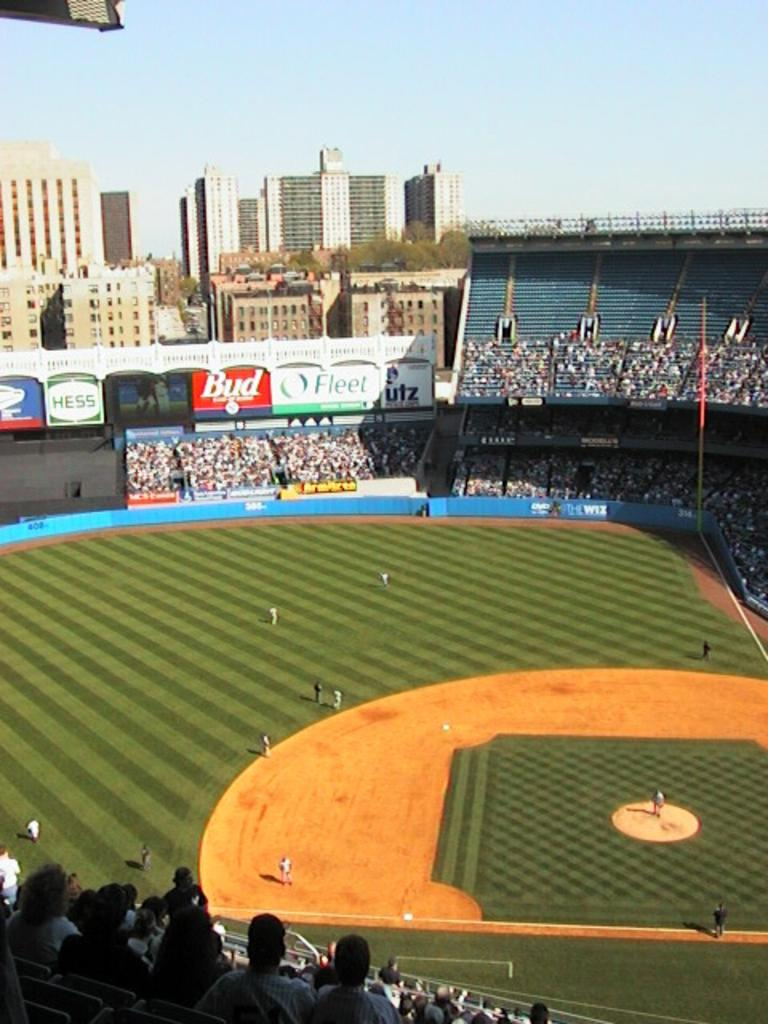Provide a one-sentence caption for the provided image. Several large billboards, including one for Hess, adorn the outfield of a baseball stadium. 